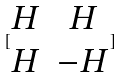Convert formula to latex. <formula><loc_0><loc_0><loc_500><loc_500>[ \begin{matrix} H & H \\ H & - H \end{matrix} ]</formula> 